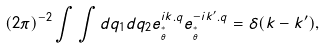<formula> <loc_0><loc_0><loc_500><loc_500>( 2 \pi ) ^ { - 2 } \int \int d q _ { 1 } d q _ { 2 } e _ { ^ { * } _ { \theta } } ^ { i k . q } e _ { ^ { * } _ { \theta } } ^ { - i k ^ { \prime } . q } = \delta ( k - k ^ { \prime } ) ,</formula> 